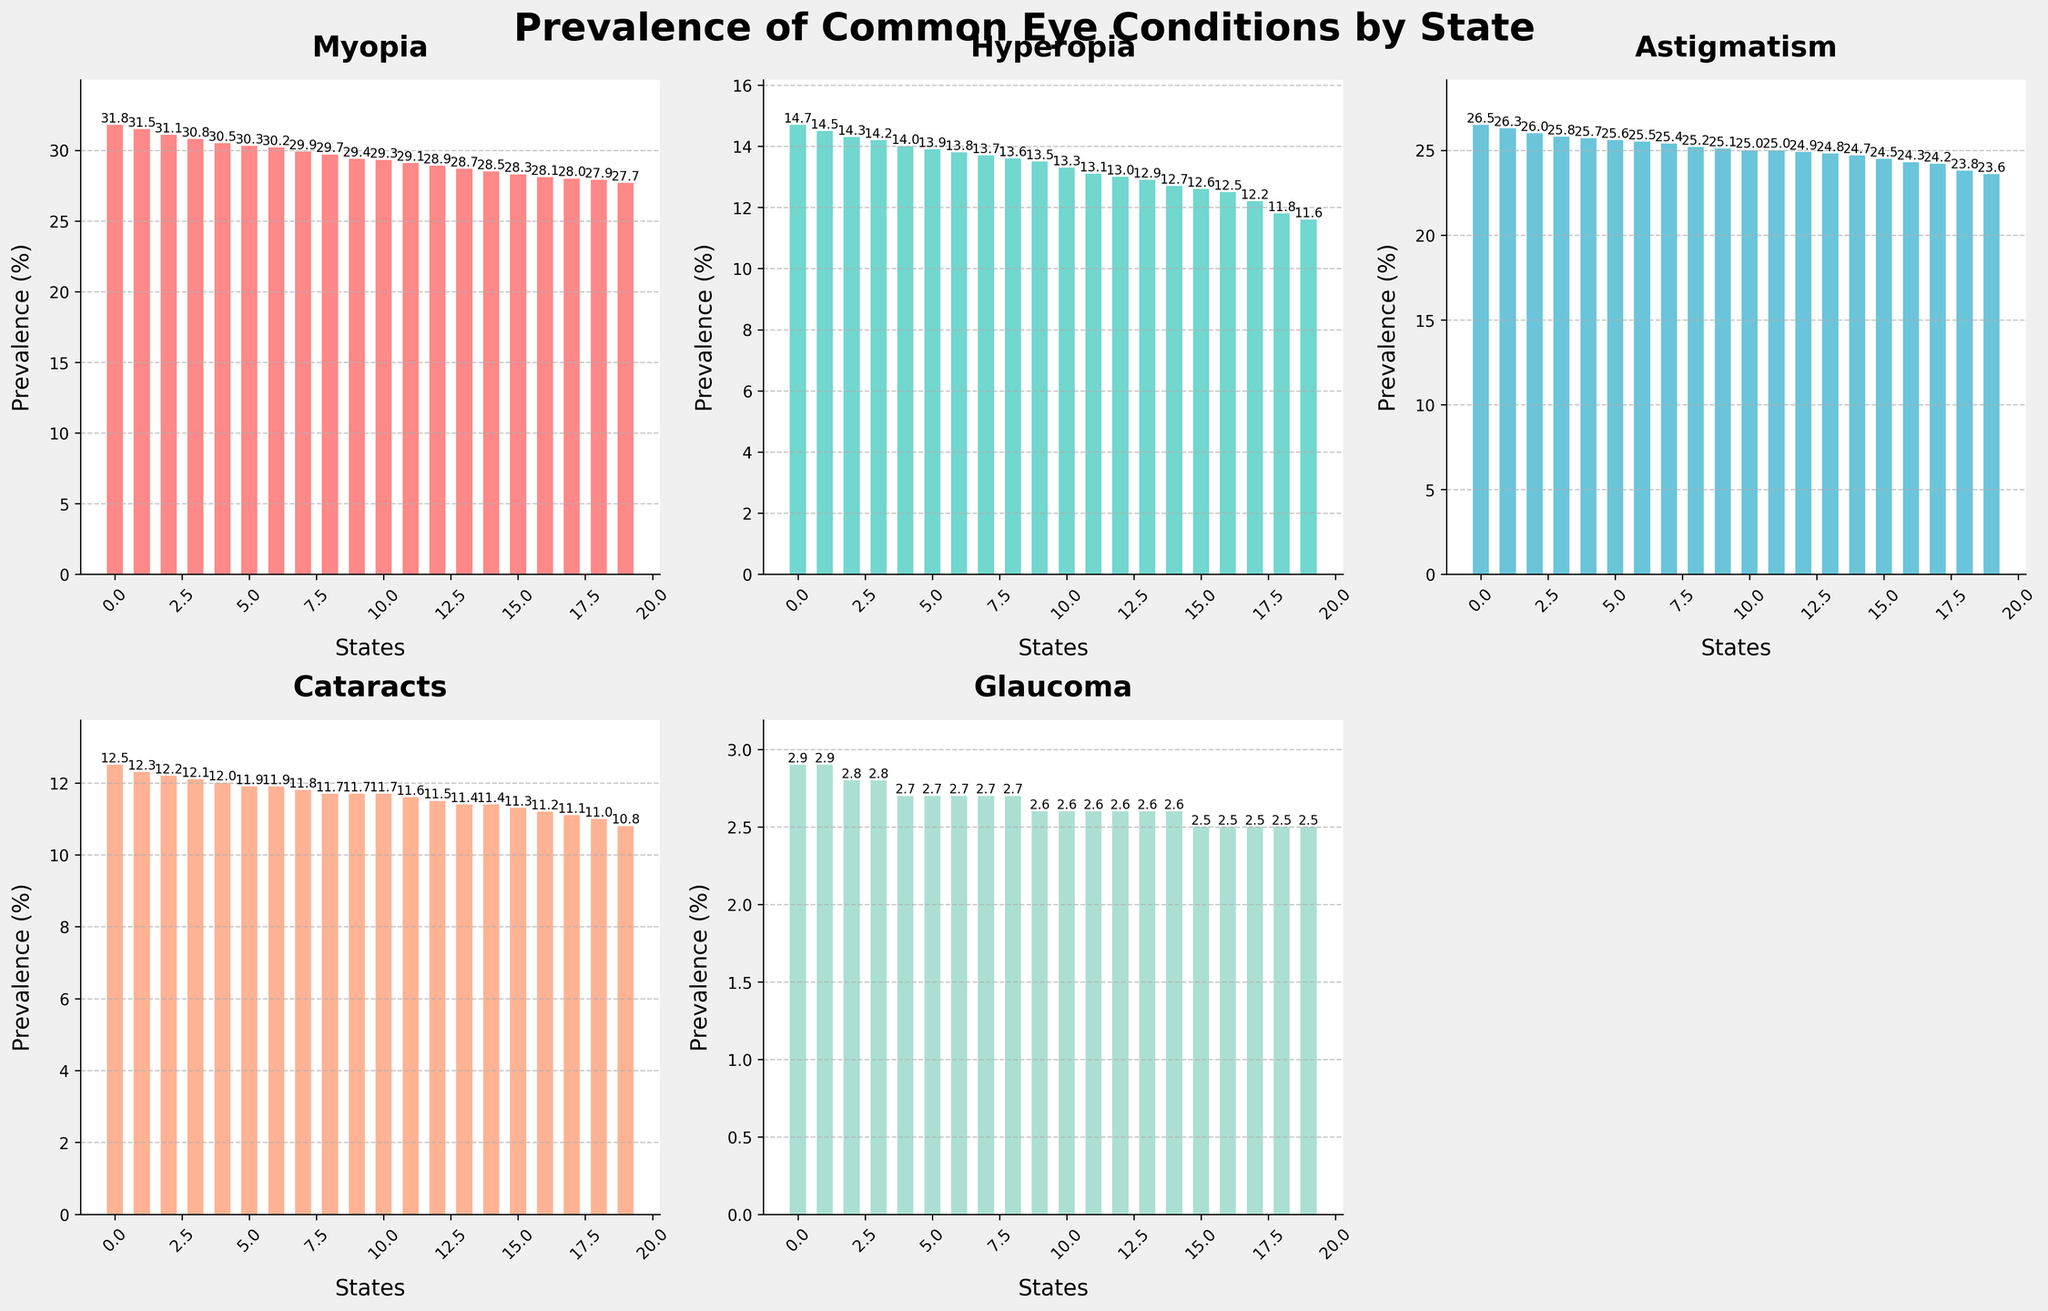What state has the highest prevalence of Myopia? Look at the bar chart for Myopia and identify the state with the tallest bar. The highest bar corresponds to Massachusetts.
Answer: Massachusetts Which state has a lower prevalence of Glaucoma, California or Texas? Compare the heights of the bars for Glaucoma in the California and Texas sections. The bar for Texas is lower than the bar for California.
Answer: Texas What's the average prevalence of Hyperopia in Florida, Pennsylvania, and Illinois? Add the Hyperopia values for Florida (14.2), Pennsylvania (13.7), and Illinois (12.9), then divide by 3. (14.2 + 13.7 + 12.9) / 3 = 13.6
Answer: 13.6 Which condition has the most even distribution of prevalence across all states? Compare the lengths and variations of the bars for each condition. Hyperopia appears to have the most evenly distributed bar lengths across the states.
Answer: Hyperopia What is the difference in prevalence of Cataracts between Michigan and Tennessee? Subtract the prevalence of Cataracts in Michigan (11.8) from that in Tennessee (12.5). 12.5 - 11.8 = 0.7
Answer: 0.7 What state has the lowest prevalence of Astigmatism? Look for the shortest bar in the Astigmatism subplot. The shortest bar corresponds to Tennessee.
Answer: Tennessee Which state has a higher prevalence of Cataracts, New York or Missouri? Compare the heights of the bars for Cataracts in New York and Missouri. The bar for New York (11.7) is shorter than the bar for Missouri (12.2).
Answer: Missouri What's the combined prevalence of Myopia and Hyperopia in Georgia? Add the Myopia value (29.7) and Hyperopia value (13.3) for Georgia. 29.7 + 13.3 = 43.0
Answer: 43.0 In which condition does New York rank higher in prevalence compared to Maryland? Compare the heights of the bars for all conditions between New York and Maryland, and identify the condition where New York has a considerably taller bar. This is true for Hyperopia (New York: 11.8, Maryland: 12.6).
Answer: None Which state has the second-highest prevalence of Myopia? Sort the Myopia values in descending order and identify the second-highest value, which corresponds to New York (31.5)
Answer: New York 